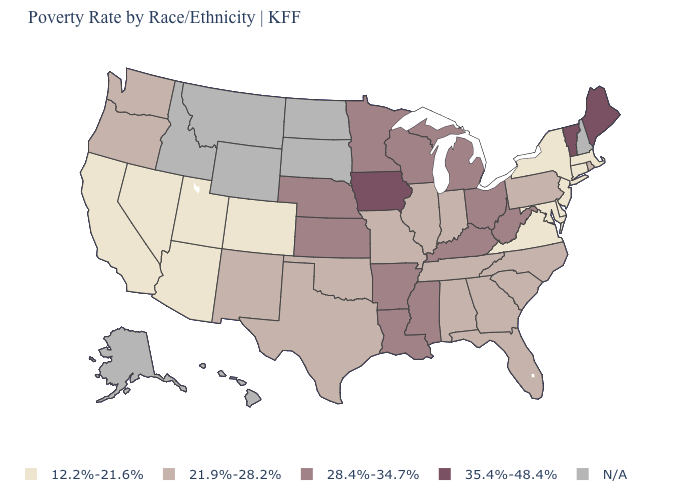What is the value of Missouri?
Write a very short answer. 21.9%-28.2%. Does the map have missing data?
Short answer required. Yes. What is the value of Texas?
Write a very short answer. 21.9%-28.2%. How many symbols are there in the legend?
Quick response, please. 5. How many symbols are there in the legend?
Short answer required. 5. Does California have the lowest value in the West?
Give a very brief answer. Yes. What is the highest value in the South ?
Answer briefly. 28.4%-34.7%. Is the legend a continuous bar?
Concise answer only. No. What is the highest value in the USA?
Short answer required. 35.4%-48.4%. Among the states that border Washington , which have the lowest value?
Be succinct. Oregon. What is the value of Wyoming?
Give a very brief answer. N/A. What is the value of Michigan?
Give a very brief answer. 28.4%-34.7%. What is the value of Maryland?
Give a very brief answer. 12.2%-21.6%. What is the value of Connecticut?
Keep it brief. 12.2%-21.6%. 